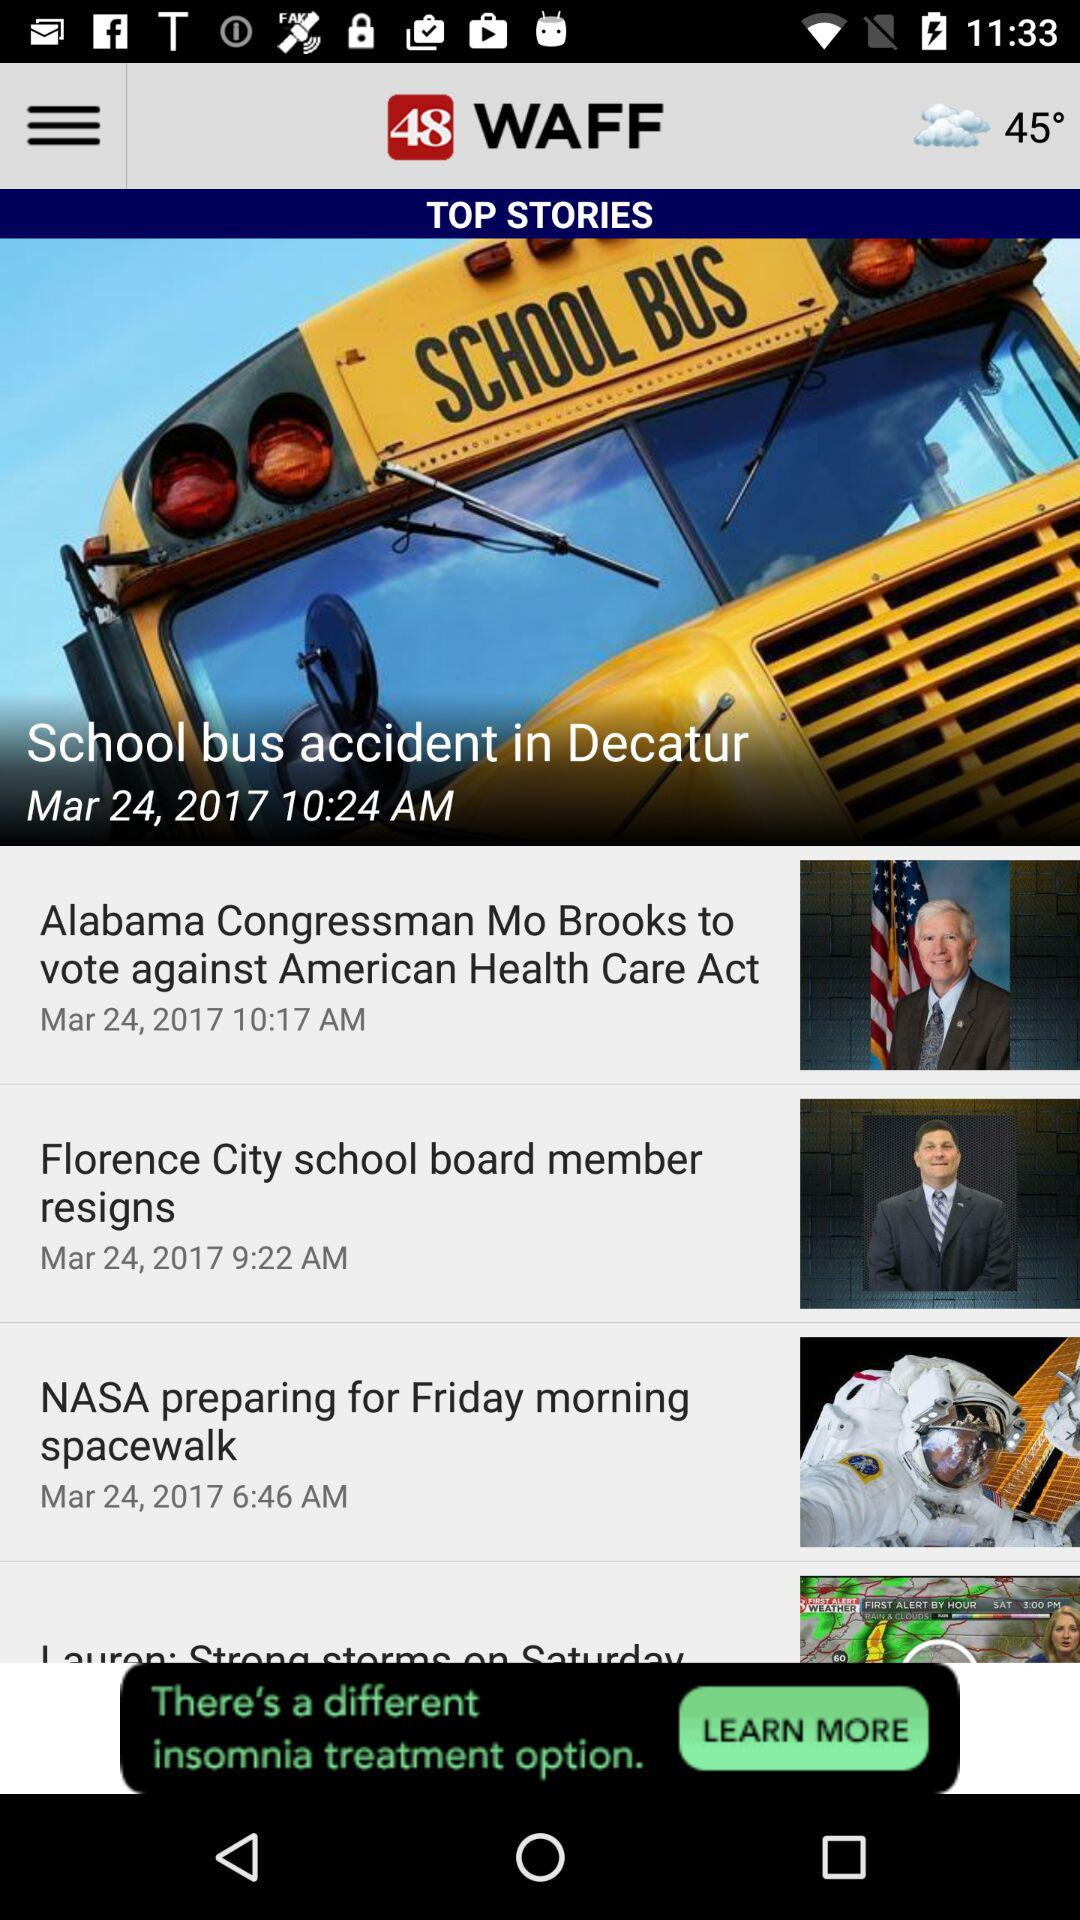What is the location of the school bus accident? The location of the school bus accident is Decatur. 